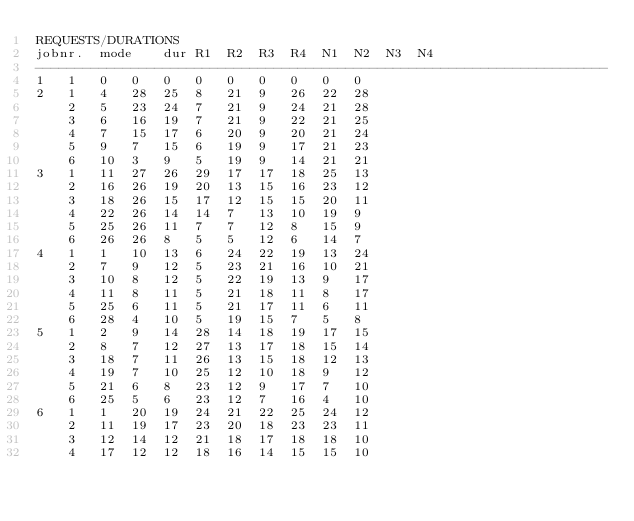Convert code to text. <code><loc_0><loc_0><loc_500><loc_500><_ObjectiveC_>REQUESTS/DURATIONS
jobnr.	mode	dur	R1	R2	R3	R4	N1	N2	N3	N4	
------------------------------------------------------------------------
1	1	0	0	0	0	0	0	0	0	0	
2	1	4	28	25	8	21	9	26	22	28	
	2	5	23	24	7	21	9	24	21	28	
	3	6	16	19	7	21	9	22	21	25	
	4	7	15	17	6	20	9	20	21	24	
	5	9	7	15	6	19	9	17	21	23	
	6	10	3	9	5	19	9	14	21	21	
3	1	11	27	26	29	17	17	18	25	13	
	2	16	26	19	20	13	15	16	23	12	
	3	18	26	15	17	12	15	15	20	11	
	4	22	26	14	14	7	13	10	19	9	
	5	25	26	11	7	7	12	8	15	9	
	6	26	26	8	5	5	12	6	14	7	
4	1	1	10	13	6	24	22	19	13	24	
	2	7	9	12	5	23	21	16	10	21	
	3	10	8	12	5	22	19	13	9	17	
	4	11	8	11	5	21	18	11	8	17	
	5	25	6	11	5	21	17	11	6	11	
	6	28	4	10	5	19	15	7	5	8	
5	1	2	9	14	28	14	18	19	17	15	
	2	8	7	12	27	13	17	18	15	14	
	3	18	7	11	26	13	15	18	12	13	
	4	19	7	10	25	12	10	18	9	12	
	5	21	6	8	23	12	9	17	7	10	
	6	25	5	6	23	12	7	16	4	10	
6	1	1	20	19	24	21	22	25	24	12	
	2	11	19	17	23	20	18	23	23	11	
	3	12	14	12	21	18	17	18	18	10	
	4	17	12	12	18	16	14	15	15	10	</code> 